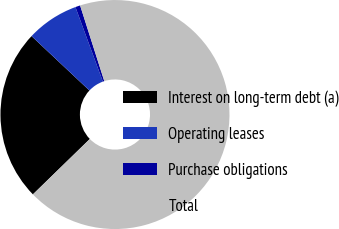<chart> <loc_0><loc_0><loc_500><loc_500><pie_chart><fcel>Interest on long-term debt (a)<fcel>Operating leases<fcel>Purchase obligations<fcel>Total<nl><fcel>24.29%<fcel>7.38%<fcel>0.69%<fcel>67.64%<nl></chart> 